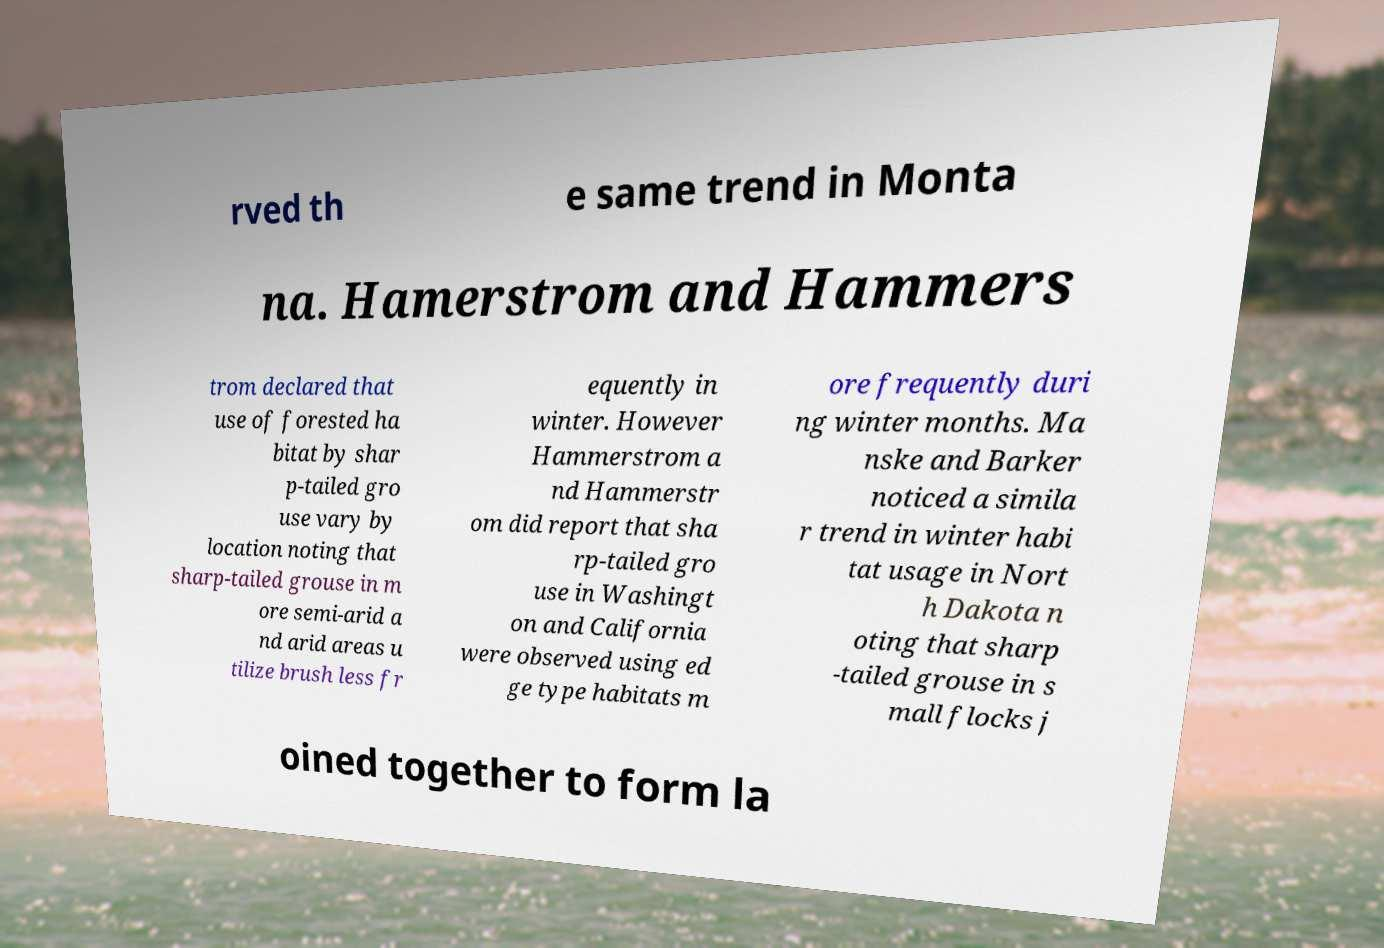Could you assist in decoding the text presented in this image and type it out clearly? rved th e same trend in Monta na. Hamerstrom and Hammers trom declared that use of forested ha bitat by shar p-tailed gro use vary by location noting that sharp-tailed grouse in m ore semi-arid a nd arid areas u tilize brush less fr equently in winter. However Hammerstrom a nd Hammerstr om did report that sha rp-tailed gro use in Washingt on and California were observed using ed ge type habitats m ore frequently duri ng winter months. Ma nske and Barker noticed a simila r trend in winter habi tat usage in Nort h Dakota n oting that sharp -tailed grouse in s mall flocks j oined together to form la 